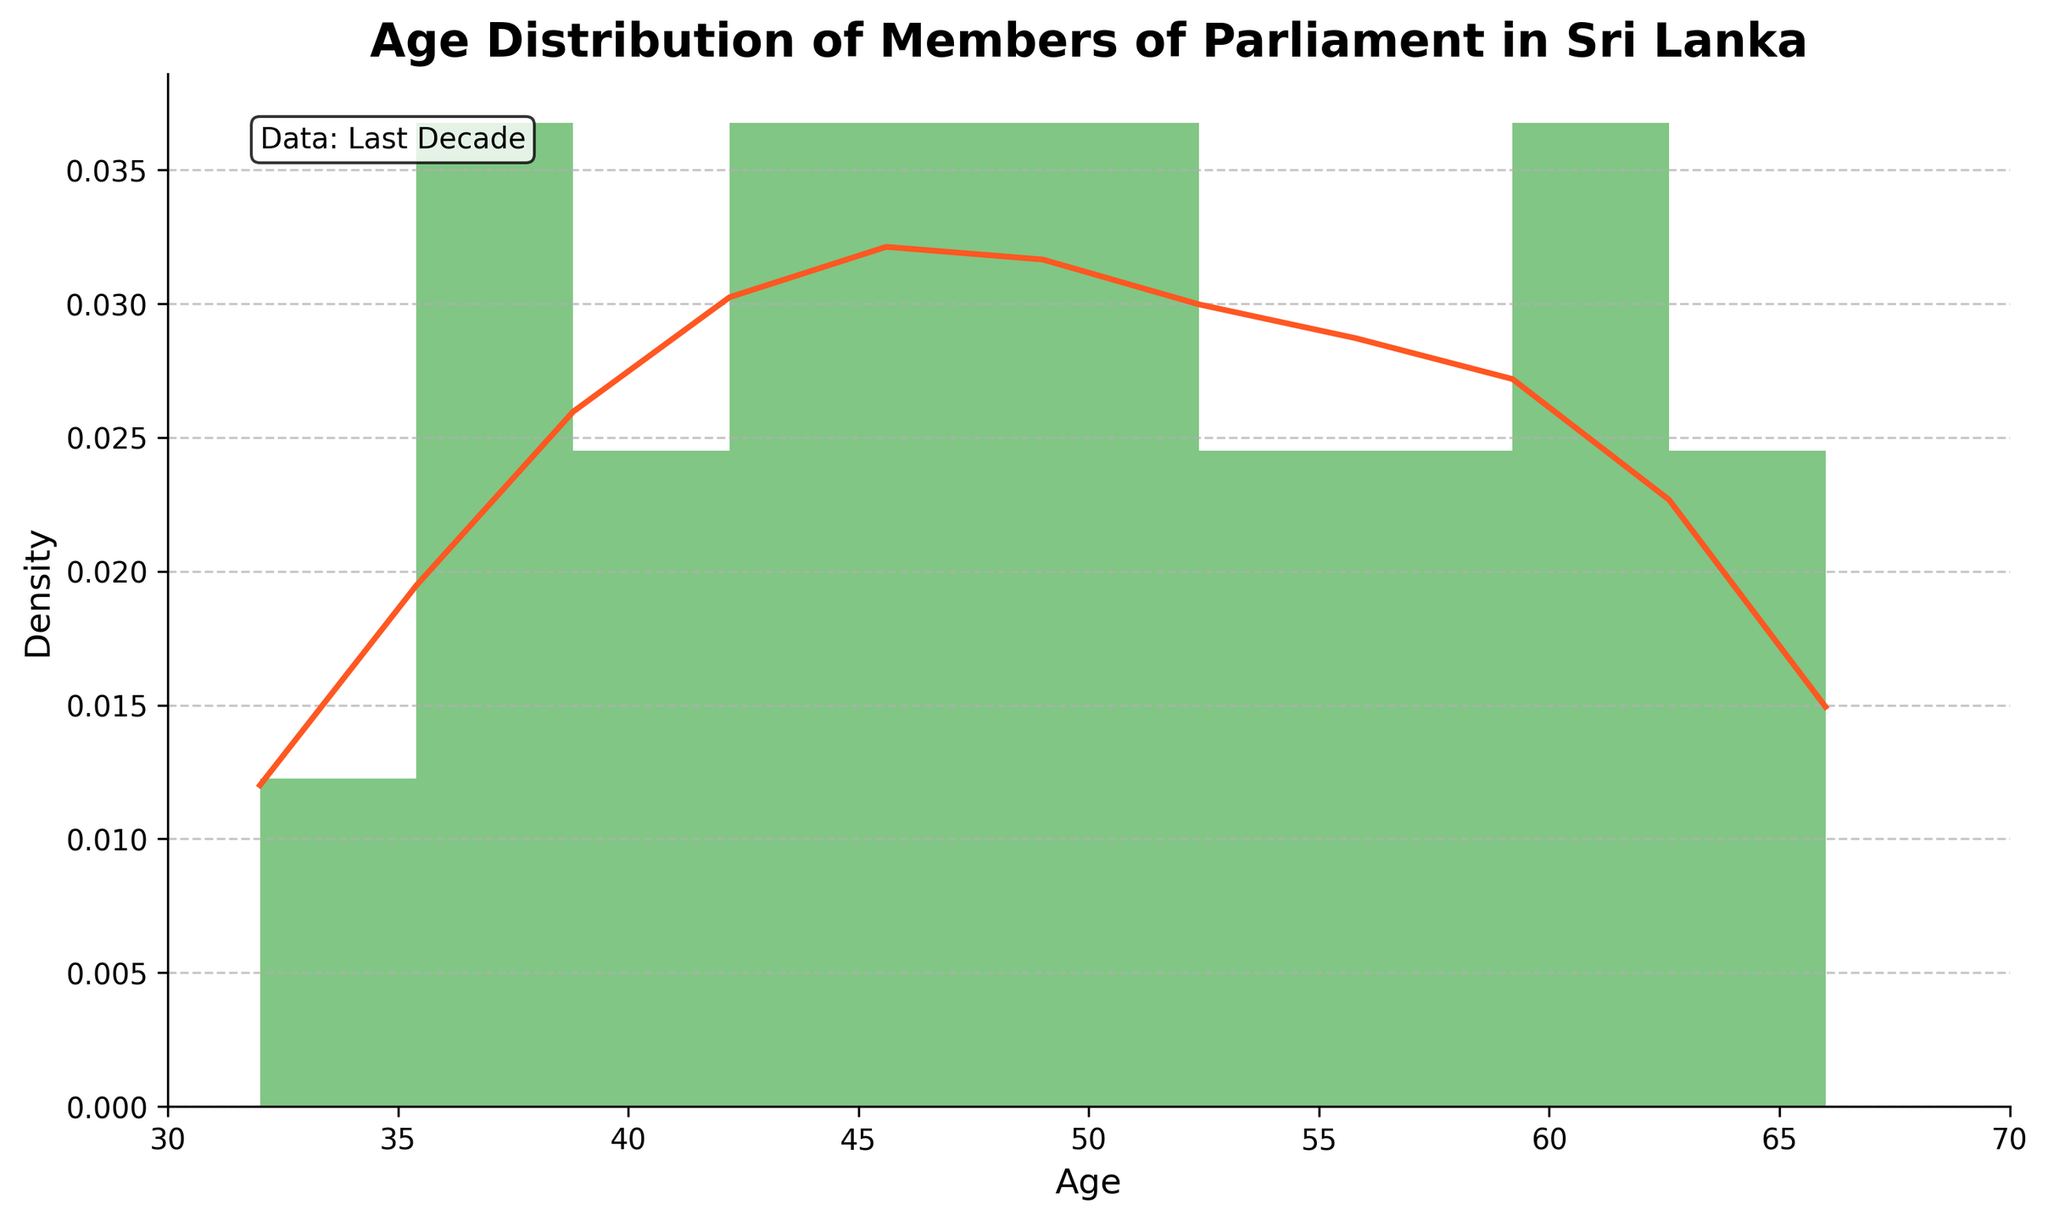What is the age range covered in the plot? The x-axis of the plot indicates the age range. From the axis, it shows the range is from 30 to 70.
Answer: 30 to 70 How many age groups are there in the histogram? The plot's x-axis shows tick marks for different age groups. Counting these divisions indicates there are 10 age groups.
Answer: 10 Which age group has the highest density of Members of Parliament? The height of the bars in the histogram reflects the density. The tallest bar represents the age group with the highest density, located around the age of 50.
Answer: Around 50 What is the shape of the age distribution? The plot combines a histogram and a KDE line. Observing the KDE line, the shape is bimodal, indicating two peaks.
Answer: Bimodal Is there a clear age group that has significantly fewer Members of Parliament? By examining both the histogram and KDE plots, the age group near 30-35 appears to have fewer members relative to others.
Answer: Around 30-35 What is the average age of Members of Parliament, based on the plot? To find an average, one would need to calculate the sum of all ages and divide by the number of members. Alternatively, you can estimate based on the histogram's central tendency, around 50.
Answer: Around 50 Which age range sees a noticeable increase in density? By examining the increasing heights of the histogram bars and the KDE line, the age range from approximately 40 to 50 shows a noticeable increase in density.
Answer: 40 to 50 Are there more Members of Parliament above or below the age of 50? Observing the histogram, the bars for ages above 50 are generally higher, indicating more Members of Parliament in this range.
Answer: Above 50 Which two age groups have the highest peaks on the KDE curve? The KDE line has two noticeable peaks, one at around 50 and another smaller peak near 60.
Answer: Around 50 and 60 Does the plot suggest any skew in the age distribution? Analyzing the KDE and the histogram, while there are two peaks, the distribution slightly skews to the older age groups, noticeable in higher density at older ages (toward 60).
Answer: Slight right skew 